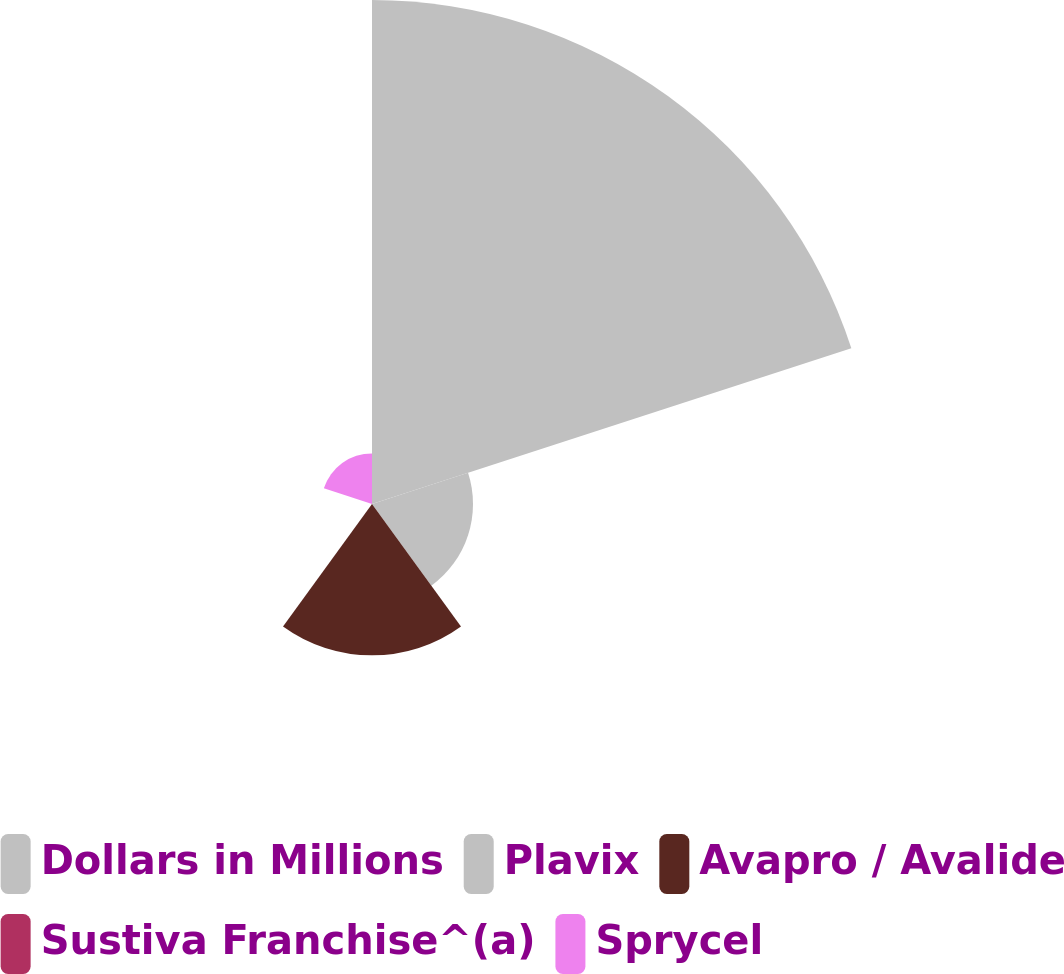Convert chart to OTSL. <chart><loc_0><loc_0><loc_500><loc_500><pie_chart><fcel>Dollars in Millions<fcel>Plavix<fcel>Avapro / Avalide<fcel>Sustiva Franchise^(a)<fcel>Sprycel<nl><fcel>62.43%<fcel>12.51%<fcel>18.75%<fcel>0.03%<fcel>6.27%<nl></chart> 